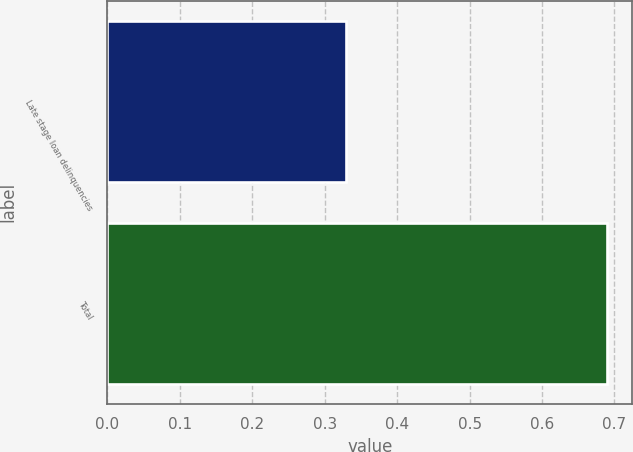Convert chart to OTSL. <chart><loc_0><loc_0><loc_500><loc_500><bar_chart><fcel>Late stage loan delinquencies<fcel>Total<nl><fcel>0.33<fcel>0.69<nl></chart> 